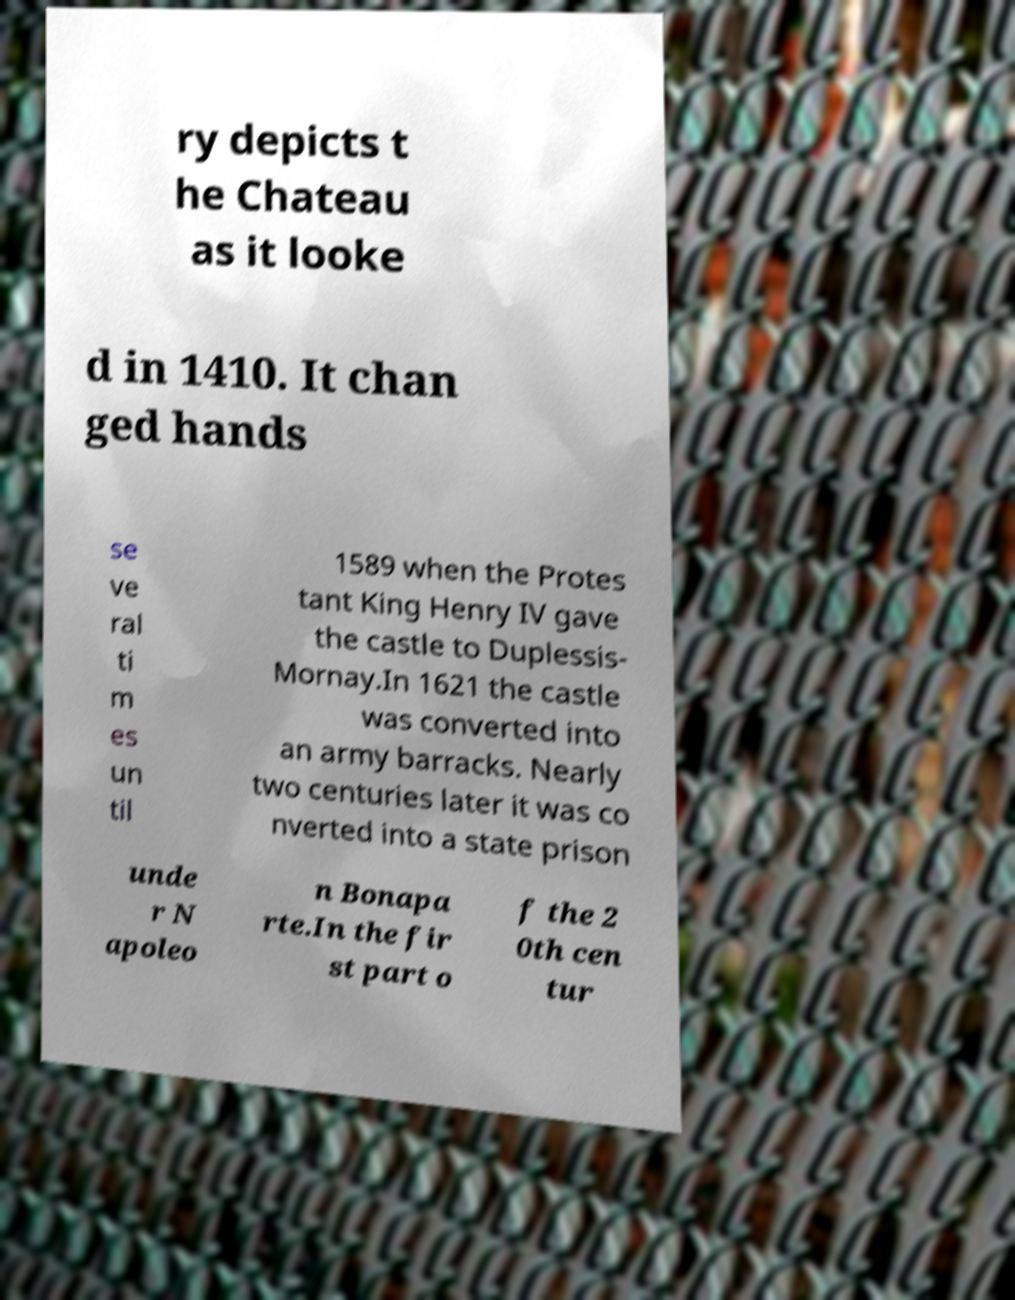What messages or text are displayed in this image? I need them in a readable, typed format. ry depicts t he Chateau as it looke d in 1410. It chan ged hands se ve ral ti m es un til 1589 when the Protes tant King Henry IV gave the castle to Duplessis- Mornay.In 1621 the castle was converted into an army barracks. Nearly two centuries later it was co nverted into a state prison unde r N apoleo n Bonapa rte.In the fir st part o f the 2 0th cen tur 